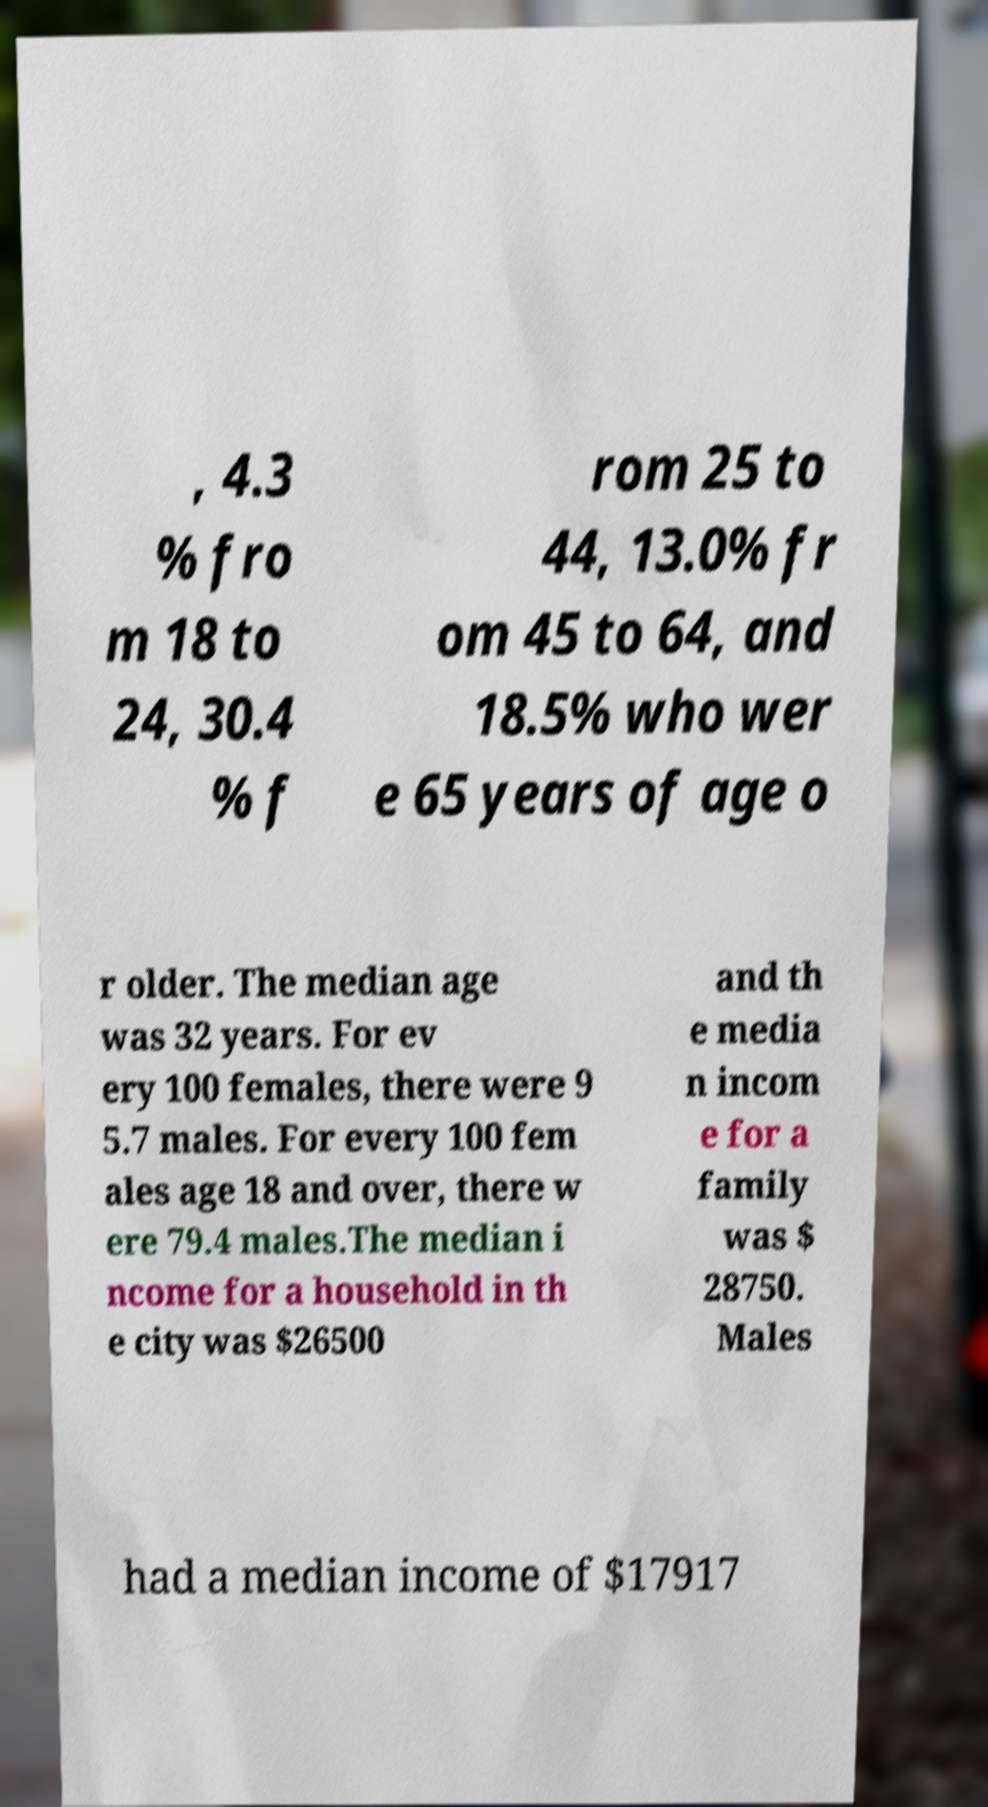Please identify and transcribe the text found in this image. , 4.3 % fro m 18 to 24, 30.4 % f rom 25 to 44, 13.0% fr om 45 to 64, and 18.5% who wer e 65 years of age o r older. The median age was 32 years. For ev ery 100 females, there were 9 5.7 males. For every 100 fem ales age 18 and over, there w ere 79.4 males.The median i ncome for a household in th e city was $26500 and th e media n incom e for a family was $ 28750. Males had a median income of $17917 